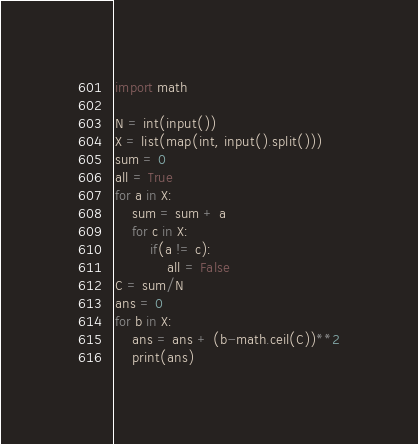Convert code to text. <code><loc_0><loc_0><loc_500><loc_500><_Python_>import math
 
N = int(input())
X = list(map(int, input().split()))
sum = 0
all = True
for a in X:
    sum = sum + a
    for c in X:
        if(a != c):
            all = False
C = sum/N
ans = 0
for b in X:
    ans = ans + (b-math.ceil(C))**2
    print(ans)</code> 